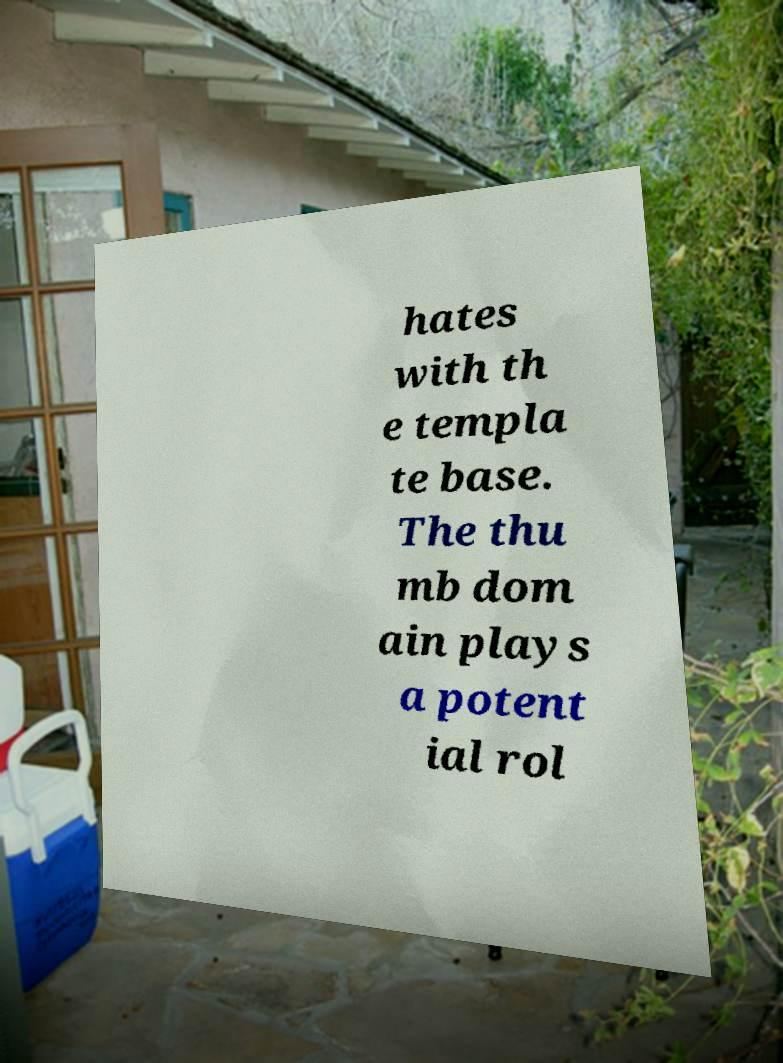I need the written content from this picture converted into text. Can you do that? hates with th e templa te base. The thu mb dom ain plays a potent ial rol 